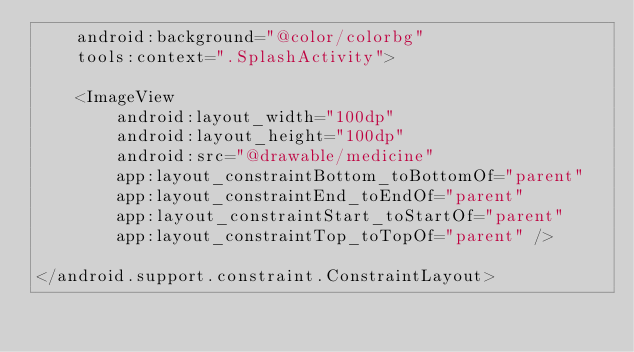Convert code to text. <code><loc_0><loc_0><loc_500><loc_500><_XML_>    android:background="@color/colorbg"
    tools:context=".SplashActivity">

    <ImageView
        android:layout_width="100dp"
        android:layout_height="100dp"
        android:src="@drawable/medicine"
        app:layout_constraintBottom_toBottomOf="parent"
        app:layout_constraintEnd_toEndOf="parent"
        app:layout_constraintStart_toStartOf="parent"
        app:layout_constraintTop_toTopOf="parent" />

</android.support.constraint.ConstraintLayout></code> 